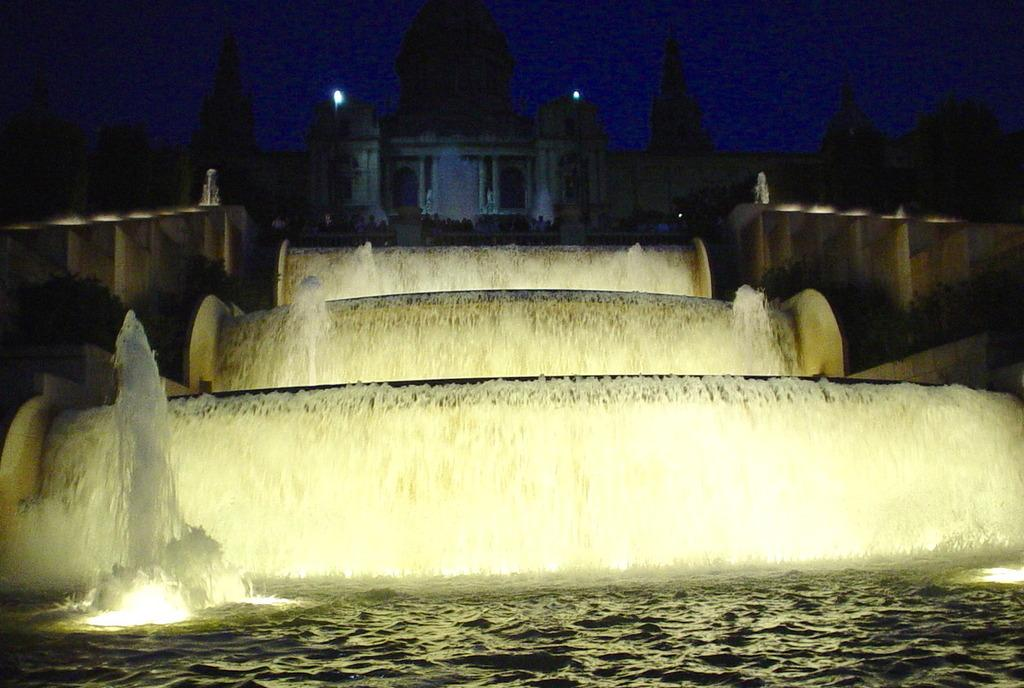What is the main feature in the image? There is a fountain in the image. Where is the fountain located in relation to the building? The fountain is in front of a building. What can be seen on both sides of the image? There are walls on the left and right sides of the image. What is visible at the top of the image? The sky is visible at the top of the image. What type of stew can be seen simmering in the fountain in the image? There is no stew present in the image; it features a fountain with water. What amusement park rides can be seen in the background of the image? There are no amusement park rides visible in the image; it only shows a fountain, a building, and walls. 